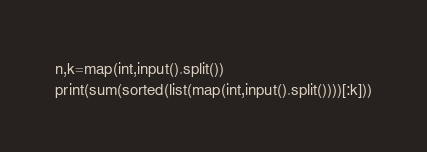Convert code to text. <code><loc_0><loc_0><loc_500><loc_500><_Python_>n,k=map(int,input().split())
print(sum(sorted(list(map(int,input().split())))[:k]))</code> 